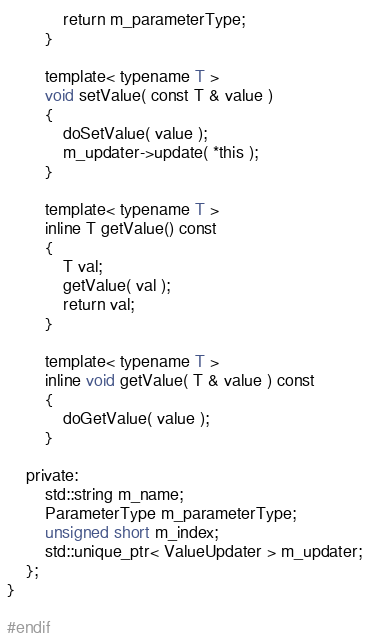Convert code to text. <code><loc_0><loc_0><loc_500><loc_500><_C++_>			return m_parameterType;
		}

		template< typename T >
		void setValue( const T & value )
		{
			doSetValue( value );
			m_updater->update( *this );
		}

		template< typename T >
		inline T getValue() const
		{
			T val;
			getValue( val );
			return val;
		}

		template< typename T >
		inline void getValue( T & value ) const
		{
			doGetValue( value );
		}

	private:
		std::string m_name;
		ParameterType m_parameterType;
		unsigned short m_index;
		std::unique_ptr< ValueUpdater > m_updater;
	};
}

#endif
</code> 